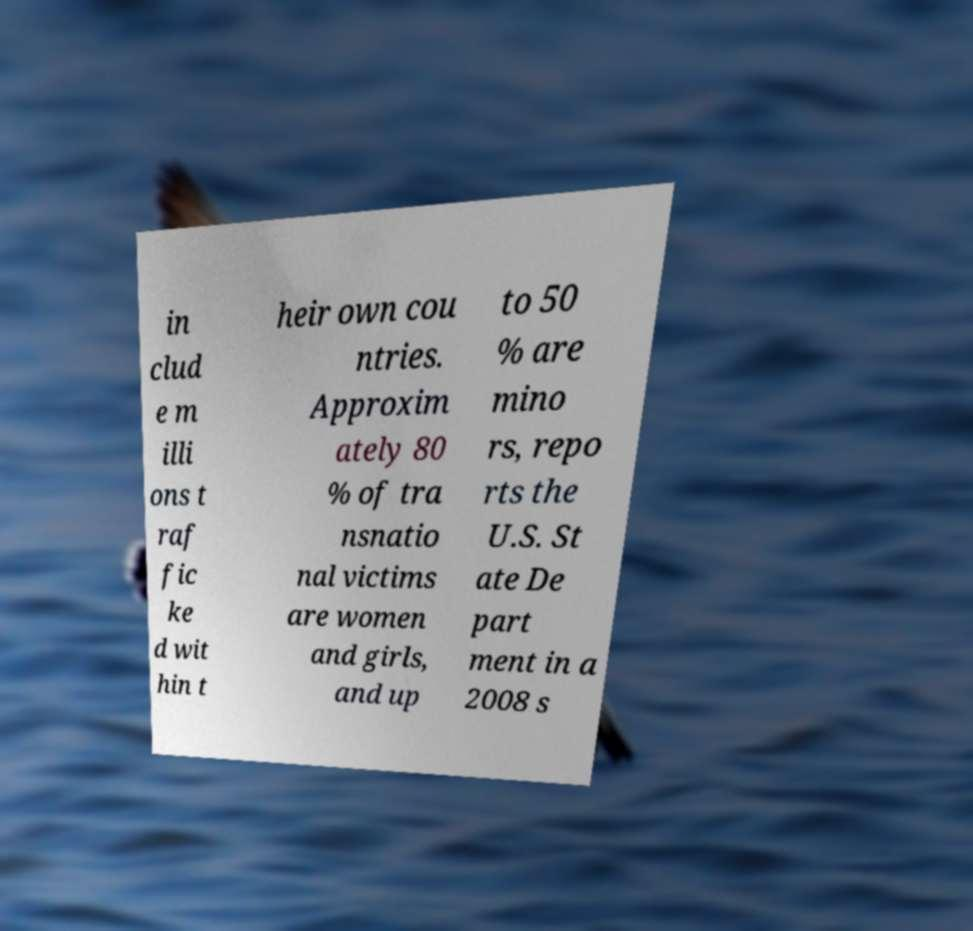Can you read and provide the text displayed in the image?This photo seems to have some interesting text. Can you extract and type it out for me? in clud e m illi ons t raf fic ke d wit hin t heir own cou ntries. Approxim ately 80 % of tra nsnatio nal victims are women and girls, and up to 50 % are mino rs, repo rts the U.S. St ate De part ment in a 2008 s 